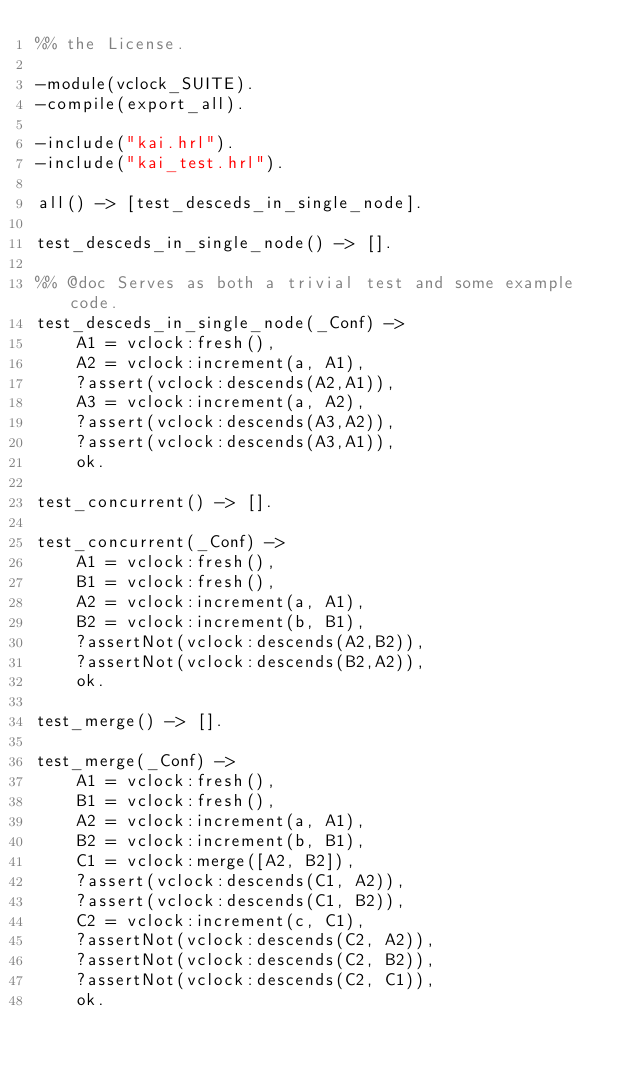<code> <loc_0><loc_0><loc_500><loc_500><_Erlang_>%% the License.

-module(vclock_SUITE).
-compile(export_all).

-include("kai.hrl").
-include("kai_test.hrl").

all() -> [test_desceds_in_single_node].

test_desceds_in_single_node() -> [].

%% @doc Serves as both a trivial test and some example code.
test_desceds_in_single_node(_Conf) ->
    A1 = vclock:fresh(),
    A2 = vclock:increment(a, A1),
    ?assert(vclock:descends(A2,A1)),
    A3 = vclock:increment(a, A2),
    ?assert(vclock:descends(A3,A2)),
    ?assert(vclock:descends(A3,A1)),
    ok.

test_concurrent() -> [].

test_concurrent(_Conf) ->
    A1 = vclock:fresh(),
    B1 = vclock:fresh(),
    A2 = vclock:increment(a, A1),
    B2 = vclock:increment(b, B1),
    ?assertNot(vclock:descends(A2,B2)),
    ?assertNot(vclock:descends(B2,A2)),
    ok.

test_merge() -> [].

test_merge(_Conf) ->
    A1 = vclock:fresh(),
    B1 = vclock:fresh(),
    A2 = vclock:increment(a, A1),
    B2 = vclock:increment(b, B1),
    C1 = vclock:merge([A2, B2]),
    ?assert(vclock:descends(C1, A2)),
    ?assert(vclock:descends(C1, B2)),
    C2 = vclock:increment(c, C1),
    ?assertNot(vclock:descends(C2, A2)),
    ?assertNot(vclock:descends(C2, B2)),
    ?assertNot(vclock:descends(C2, C1)),
    ok.
</code> 